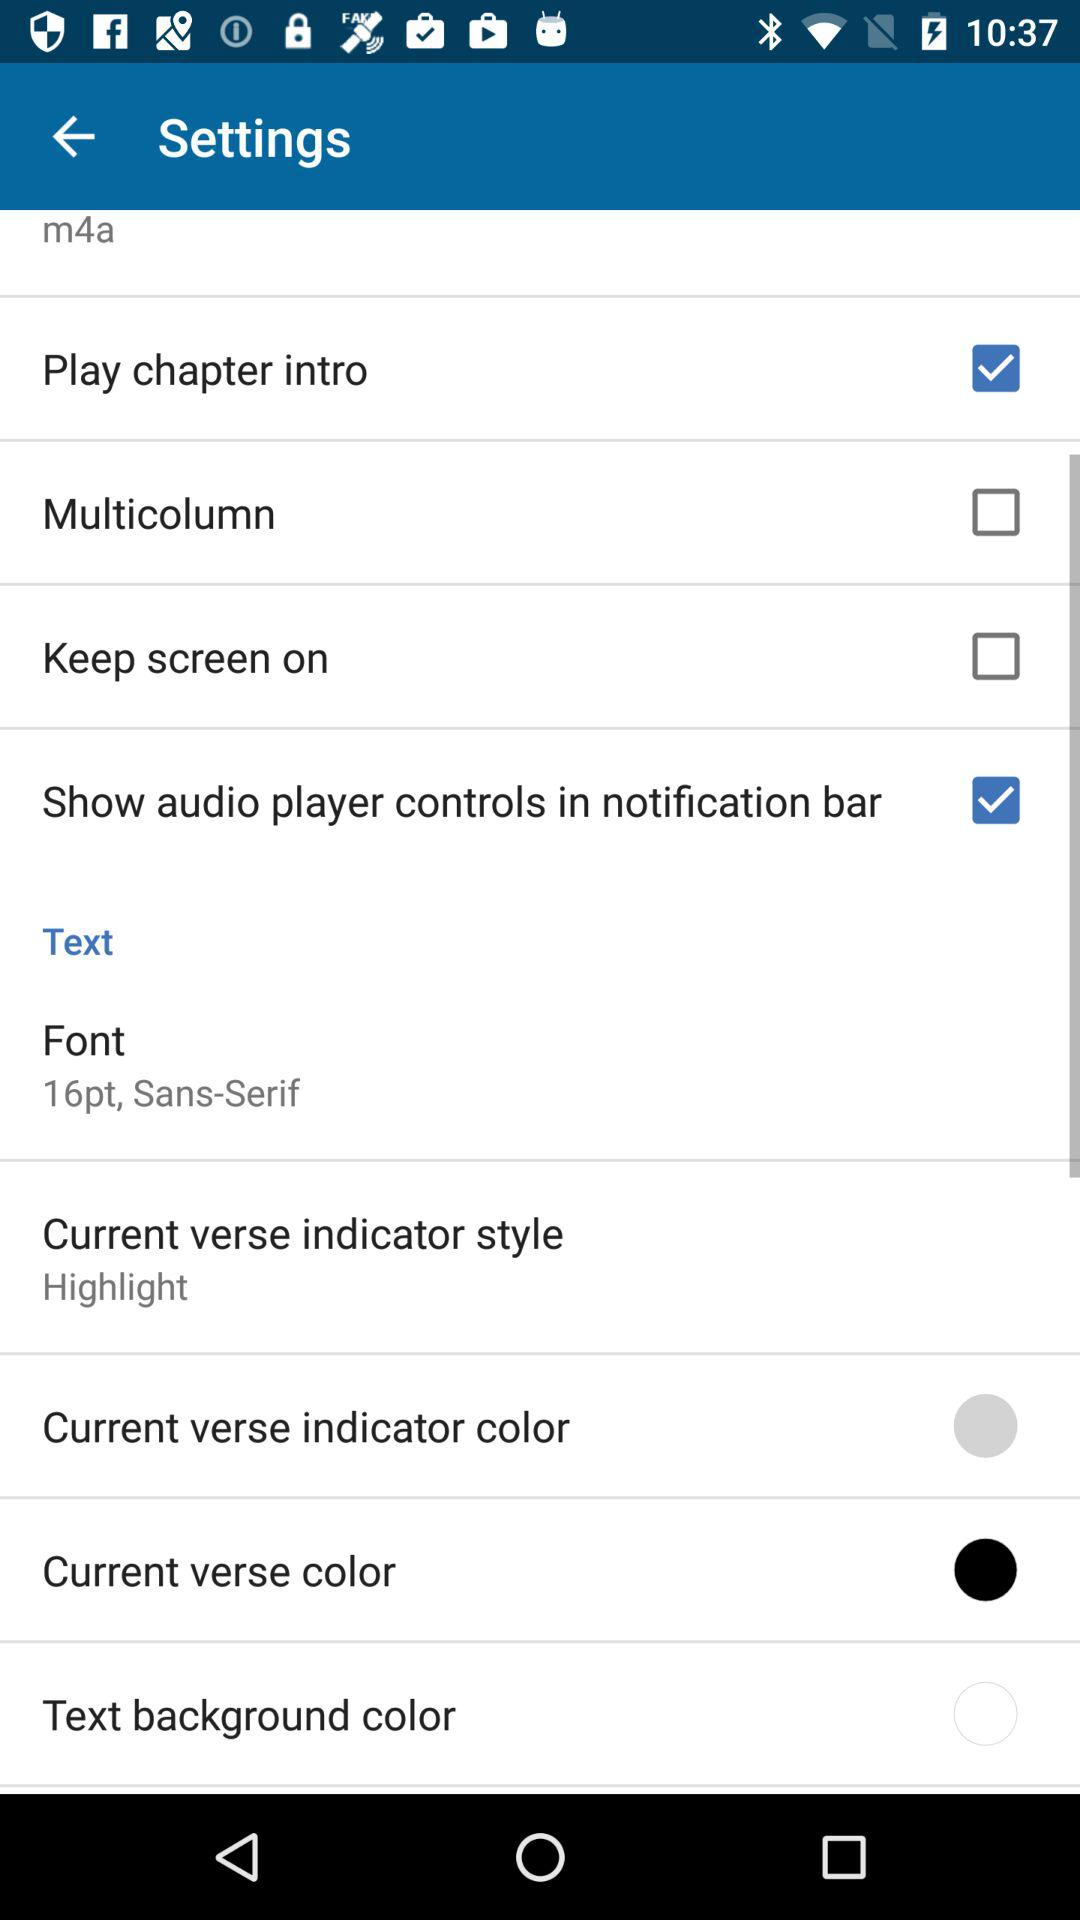Is the text font bold?
When the provided information is insufficient, respond with <no answer>. <no answer> 